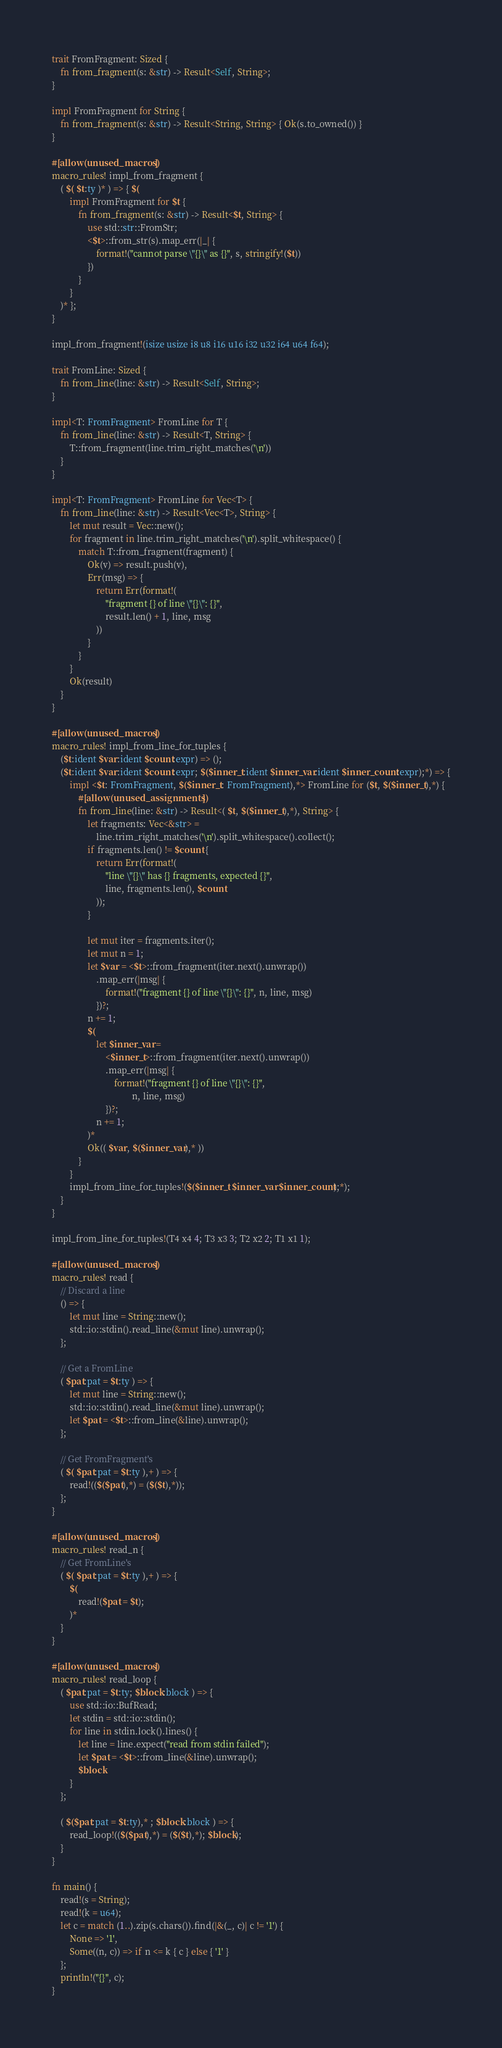Convert code to text. <code><loc_0><loc_0><loc_500><loc_500><_Rust_>trait FromFragment: Sized {
    fn from_fragment(s: &str) -> Result<Self, String>;
}

impl FromFragment for String {
    fn from_fragment(s: &str) -> Result<String, String> { Ok(s.to_owned()) }
}

#[allow(unused_macros)]
macro_rules! impl_from_fragment {
    ( $( $t:ty )* ) => { $(
        impl FromFragment for $t {
            fn from_fragment(s: &str) -> Result<$t, String> {
                use std::str::FromStr;
                <$t>::from_str(s).map_err(|_| {
                    format!("cannot parse \"{}\" as {}", s, stringify!($t))
                })
            }
        }
    )* };
}

impl_from_fragment!(isize usize i8 u8 i16 u16 i32 u32 i64 u64 f64);

trait FromLine: Sized {
    fn from_line(line: &str) -> Result<Self, String>;
}

impl<T: FromFragment> FromLine for T {
    fn from_line(line: &str) -> Result<T, String> {
        T::from_fragment(line.trim_right_matches('\n'))
    }
}

impl<T: FromFragment> FromLine for Vec<T> {
    fn from_line(line: &str) -> Result<Vec<T>, String> {
        let mut result = Vec::new();
        for fragment in line.trim_right_matches('\n').split_whitespace() {
            match T::from_fragment(fragment) {
                Ok(v) => result.push(v),
                Err(msg) => {
                    return Err(format!(
                        "fragment {} of line \"{}\": {}",
                        result.len() + 1, line, msg
                    ))
                }
            }
        }
        Ok(result)
    }
}

#[allow(unused_macros)]
macro_rules! impl_from_line_for_tuples {
    ($t:ident $var:ident $count:expr) => ();
    ($t:ident $var:ident $count:expr; $($inner_t:ident $inner_var:ident $inner_count:expr);*) => {
        impl <$t: FromFragment, $($inner_t: FromFragment),*> FromLine for ($t, $($inner_t),*) {
            #[allow(unused_assignments)]
            fn from_line(line: &str) -> Result<( $t, $($inner_t),*), String> {
                let fragments: Vec<&str> =
                    line.trim_right_matches('\n').split_whitespace().collect();
                if fragments.len() != $count {
                    return Err(format!(
                        "line \"{}\" has {} fragments, expected {}",
                        line, fragments.len(), $count
                    ));
                }

                let mut iter = fragments.iter();
                let mut n = 1;
                let $var = <$t>::from_fragment(iter.next().unwrap())
                    .map_err(|msg| {
                        format!("fragment {} of line \"{}\": {}", n, line, msg)
                    })?;
                n += 1;
                $(
                    let $inner_var =
                        <$inner_t>::from_fragment(iter.next().unwrap())
                        .map_err(|msg| {
                            format!("fragment {} of line \"{}\": {}",
                                    n, line, msg)
                        })?;
                    n += 1;
                )*
                Ok(( $var, $($inner_var),* ))
            }
        }
        impl_from_line_for_tuples!($($inner_t $inner_var $inner_count);*);
    }
}

impl_from_line_for_tuples!(T4 x4 4; T3 x3 3; T2 x2 2; T1 x1 1);

#[allow(unused_macros)]
macro_rules! read {
    // Discard a line
    () => {
        let mut line = String::new();
        std::io::stdin().read_line(&mut line).unwrap();
    };

    // Get a FromLine
    ( $pat:pat = $t:ty ) => {
        let mut line = String::new();
        std::io::stdin().read_line(&mut line).unwrap();
        let $pat = <$t>::from_line(&line).unwrap();
    };

    // Get FromFragment's
    ( $( $pat:pat = $t:ty ),+ ) => {
        read!(($($pat),*) = ($($t),*));
    };
}

#[allow(unused_macros)]
macro_rules! read_n {
    // Get FromLine's
    ( $( $pat:pat = $t:ty ),+ ) => {
        $(
            read!($pat = $t);
        )*
    }
}

#[allow(unused_macros)]
macro_rules! read_loop {
    ( $pat:pat = $t:ty; $block:block ) => {
        use std::io::BufRead;
        let stdin = std::io::stdin();
        for line in stdin.lock().lines() {
            let line = line.expect("read from stdin failed");
            let $pat = <$t>::from_line(&line).unwrap();
            $block
        }
    };

    ( $($pat:pat = $t:ty),* ; $block:block ) => {
        read_loop!(($($pat),*) = ($($t),*); $block);
    }
}

fn main() {
    read!(s = String);
    read!(k = u64);
    let c = match (1..).zip(s.chars()).find(|&(_, c)| c != '1') {
        None => '1',
        Some((n, c)) => if n <= k { c } else { '1' }
    };
    println!("{}", c);
}
</code> 